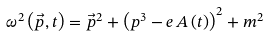<formula> <loc_0><loc_0><loc_500><loc_500>\omega ^ { 2 } \left ( \vec { p } , t \right ) = \vec { p } ^ { 2 } + \left ( p ^ { 3 } - e \, A \left ( t \right ) \right ) ^ { 2 } + m ^ { 2 }</formula> 